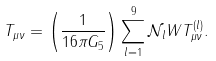<formula> <loc_0><loc_0><loc_500><loc_500>T _ { \mu \nu } = \left ( \frac { 1 } { 1 6 \pi G _ { 5 } } \right ) \sum _ { l = 1 } ^ { 9 } \mathcal { N } _ { l } W T ^ { ( l ) } _ { \mu \nu } .</formula> 